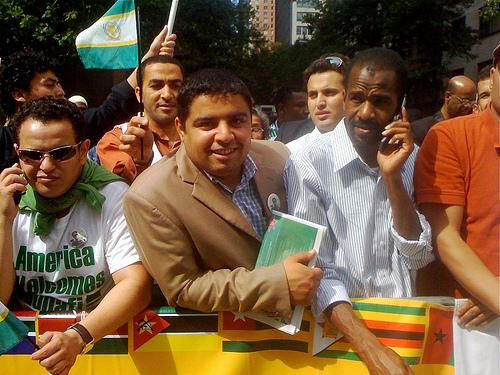Assess the quality of the image based on the image. The image appears to be of good quality, with detailed information on various objects, their positions, and sizes, allowing for a clear understanding of the scene. What is the color of the shirt with stripes? The shirt with stripes is white and blue. Provide a brief description of the scene in the image. A group of people are standing together, some holding items such as a flag, newspaper, and cell phone, and wearing various clothing items and accessories like jackets, shirts, and glasses. What objects are held by some of the people in the group? Some objects held by people in the group include a flag, a newspaper, and a cell phone. Analyze the sentiment of the overall scene in the image. The sentiment of the scene is neutral, as people are just standing together, wearing different types of clothing and holding various objects. Count and describe the types of shirts mentioned in the image's description. Three types of shirts are mentioned: a shirt with blue stripes, an orange shirt, and a shirt with green writing on it. What is happening with the man wearing sun glasses? The man is wearing retro sun glasses and is standing in the crowd. What is the emotion displayed by the smiling man in the image? The smiling man displays happiness or joy. List the colors found on the flag in the image. The flag has green, white, and yellow colors. Explain the interaction between the man holding the newspaper and the object. The man is holding a green and white newspaper in his hand, which seems to be involved in a daily routine or being examined by the man. Describe the man using an adjective. The man is happy and smiling. Identify which person is wearing a specific item. Man wearing an orange shirt. Look for a puppy playing with a blue ball at the bottom-right corner. There's no mention of a puppy or a ball in the listed objects, let alone their position in the image. The pink umbrella leaning against the fence is quite eye-catching, isn't it? No, it's not mentioned in the image. Find a child holding an ice cream cone standing next to the man with the orange shirt. None of the described objects includes a child or an ice cream cone, making this instruction misleading. Describe the overall scene in the image. People standing behind a fence, some holding objects and wearing different colored clothes, with a flag and buildings in the background. State the material of the phone. Black cell phone, material not specified. How many buttons are on the shirt? At least one small round white button. Determine the quality of the image. High quality with clear details. Can you spot a woman wearing a red hat in the image? There isn't any mention of a woman or a red hat among the listed objects. What object is one of the men holding? A cell phone. Which hand is holding the newspaper? Unable to determine. Identify the color pattern of the flag. Green, white, and yellow. What material and color is the watch band? Brown leather. Find a person that has a specific attribute. Man wearing sun glasses on top of his head. What type of building is seen in the background? Tall apartment building. Identify the emotions of the people in the photo. People are happy and smiling. What type of shirt is the man wearing? White shirt with blue stripes and green letters. What color is the man's scarf? Green. Calculate the number of people in the image. At least 9 people. Translate the text on the shirt. Unable to translate, unclear text. What is unique about the glasses on a man's face? Retro pair of sun glasses. Find the anomalies in the image. No anomalies detected. Observe the airplane flying in the sky above the tall apartment building. Although there's a mention of a tall apartment building, no objects refer to the sky or an airplane, making this instruction misleading. Describe the interaction between the people and the flag. Men standing in front of a large flag. 